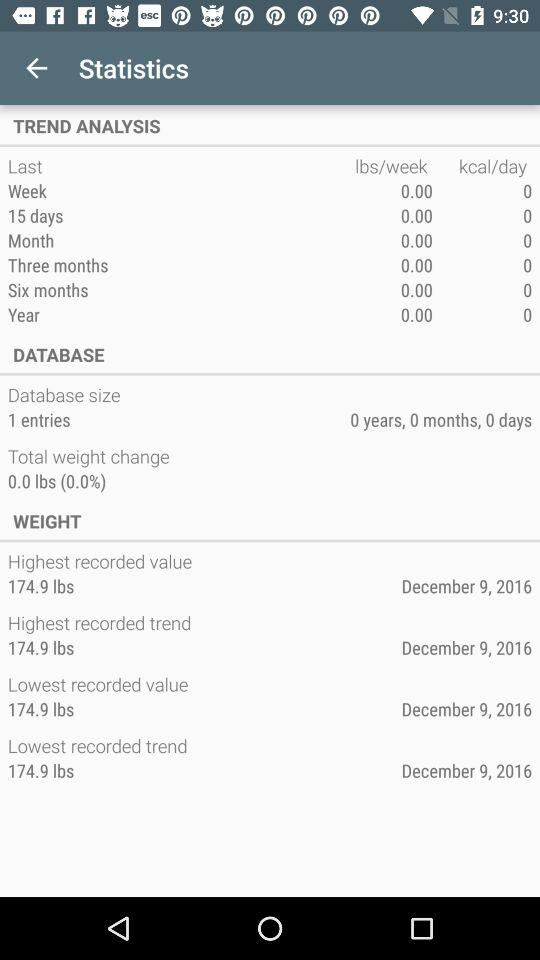Can you explain why there might be no recorded weight change over time shown in the statistics? Considering the image shows no weight change over various time frames, it might suggest that the data has not been updated beyond the initial entry or that the individual's weight is remarkably stable, maintaining at 174.9 lbs consistently. 